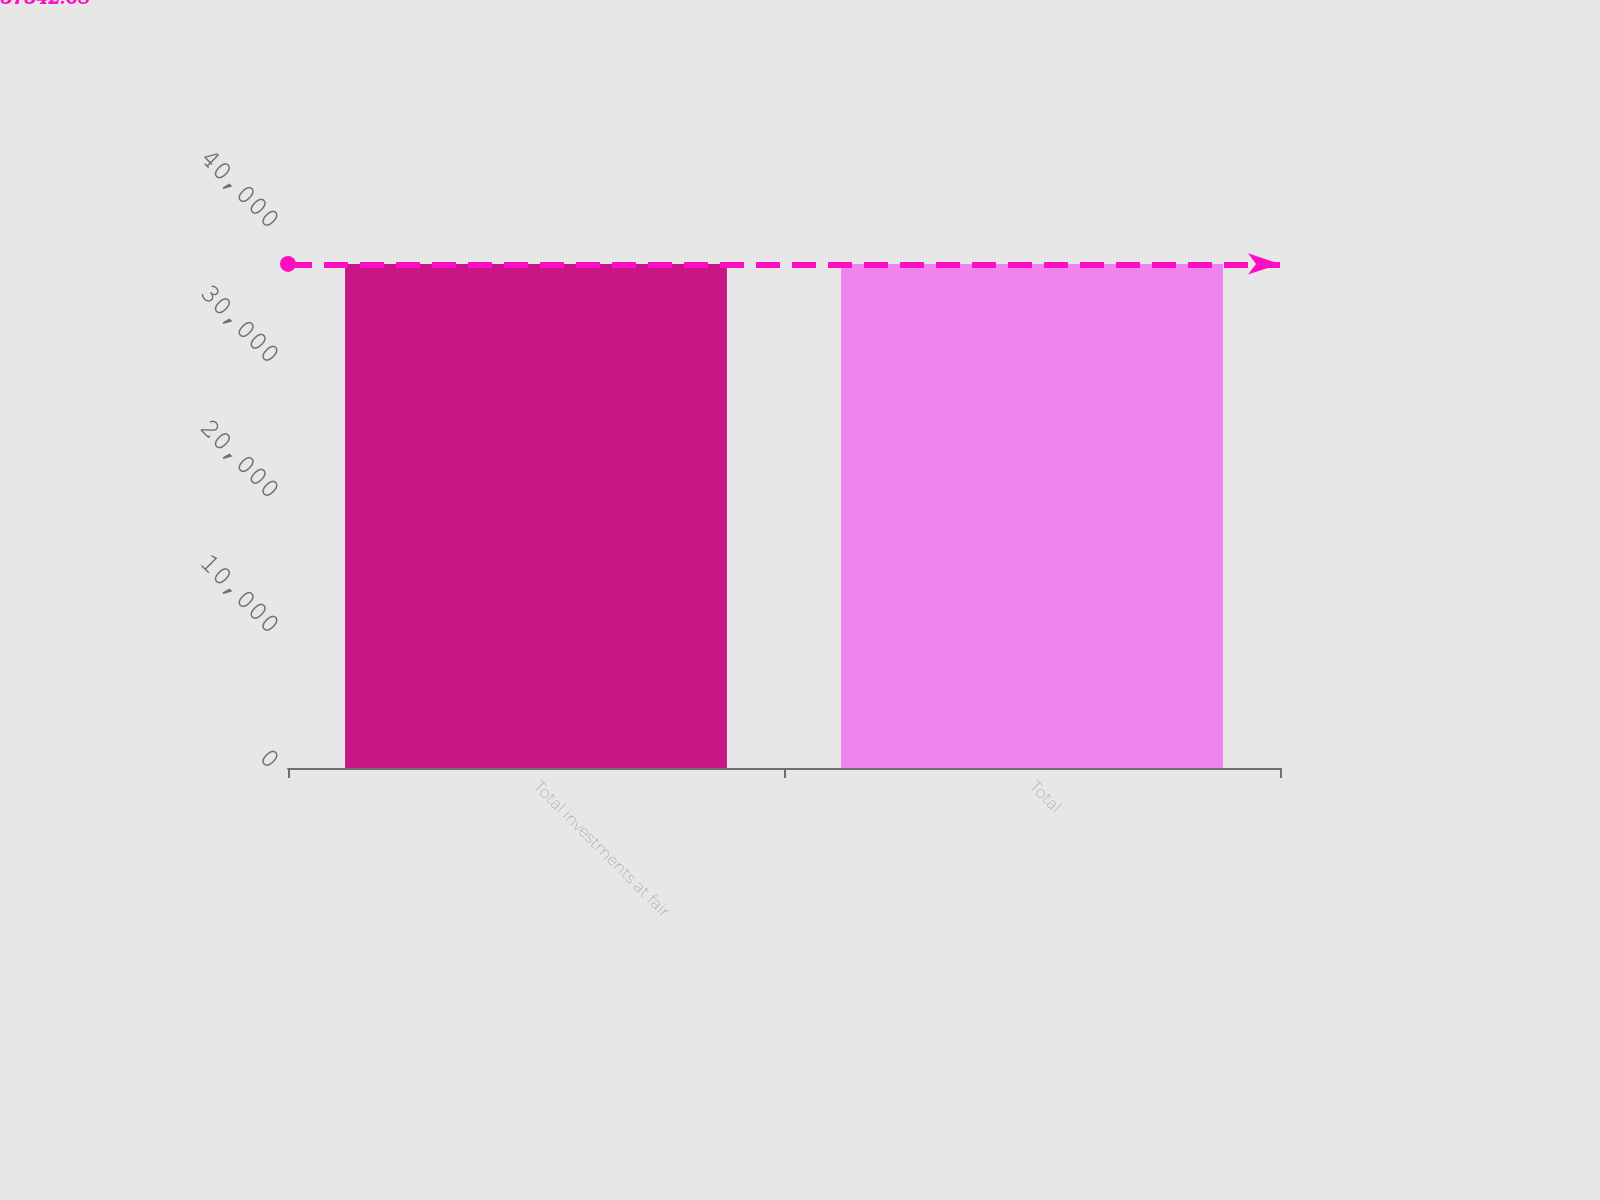<chart> <loc_0><loc_0><loc_500><loc_500><bar_chart><fcel>Total investments at fair<fcel>Total<nl><fcel>37342<fcel>37342.1<nl></chart> 